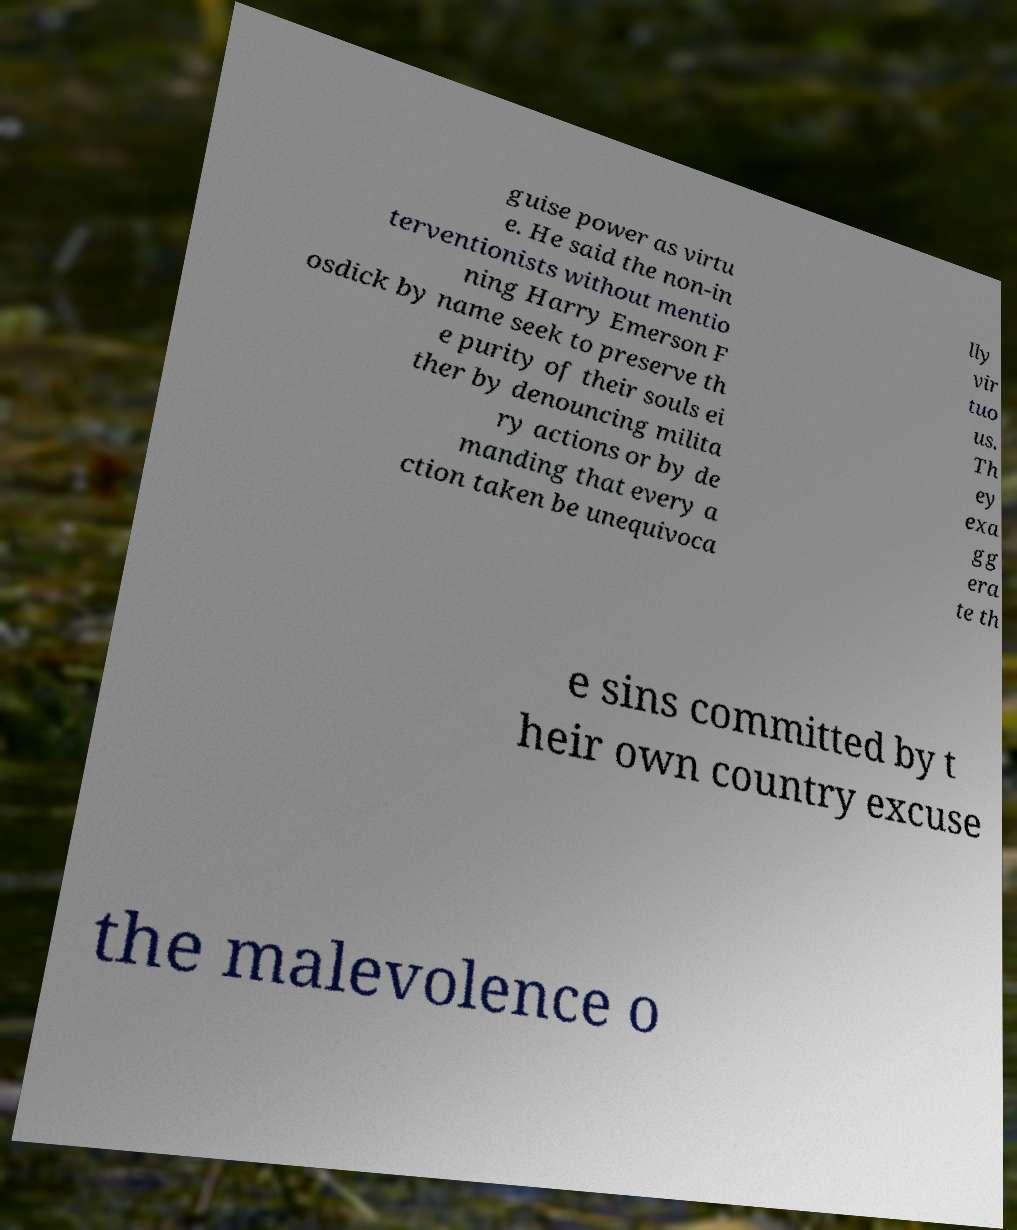Please identify and transcribe the text found in this image. guise power as virtu e. He said the non-in terventionists without mentio ning Harry Emerson F osdick by name seek to preserve th e purity of their souls ei ther by denouncing milita ry actions or by de manding that every a ction taken be unequivoca lly vir tuo us. Th ey exa gg era te th e sins committed by t heir own country excuse the malevolence o 